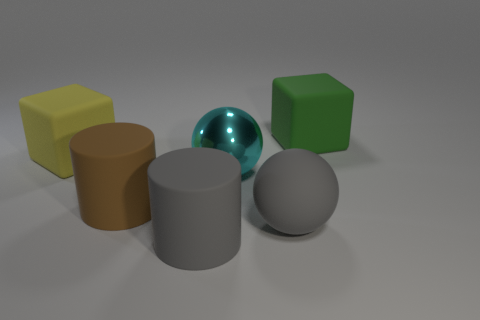The other big matte thing that is the same shape as the yellow object is what color? The object you are referring to is the large cylinder that, like the yellow cube, exhibits a matte finish. It is colored brown. 